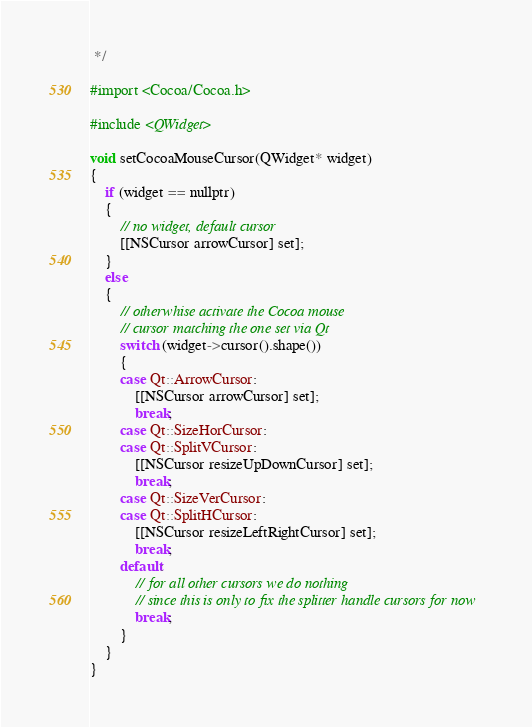Convert code to text. <code><loc_0><loc_0><loc_500><loc_500><_ObjectiveC_> */

#import <Cocoa/Cocoa.h>

#include <QWidget>

void setCocoaMouseCursor(QWidget* widget)
{
    if (widget == nullptr)
    {
        // no widget, default cursor
        [[NSCursor arrowCursor] set];
    }
    else
    {
        // otherwhise activate the Cocoa mouse
        // cursor matching the one set via Qt
        switch (widget->cursor().shape())
        {
        case Qt::ArrowCursor:
            [[NSCursor arrowCursor] set];
            break;
        case Qt::SizeHorCursor:
        case Qt::SplitVCursor:
            [[NSCursor resizeUpDownCursor] set];
            break;
        case Qt::SizeVerCursor:
        case Qt::SplitHCursor:
            [[NSCursor resizeLeftRightCursor] set];
            break;
        default:
            // for all other cursors we do nothing
            // since this is only to fix the splitter handle cursors for now
            break;
        }
    }
}
</code> 